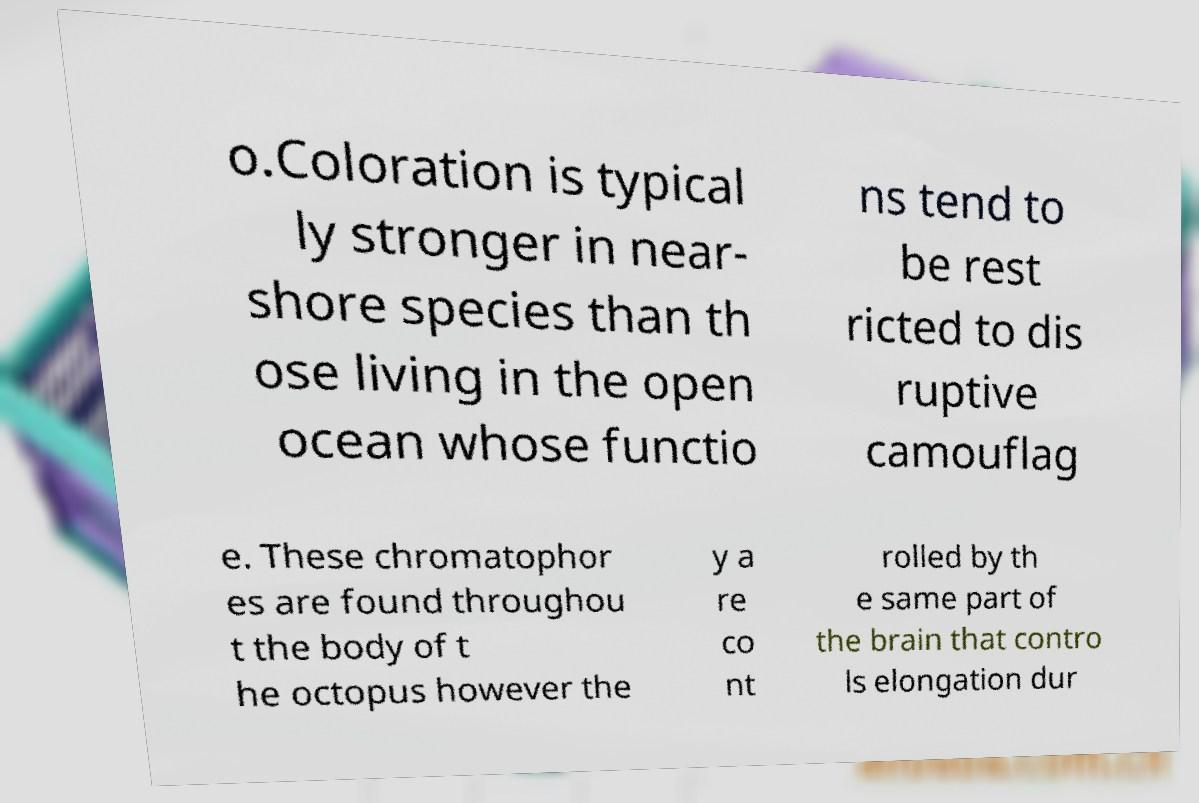I need the written content from this picture converted into text. Can you do that? o.Coloration is typical ly stronger in near- shore species than th ose living in the open ocean whose functio ns tend to be rest ricted to dis ruptive camouflag e. These chromatophor es are found throughou t the body of t he octopus however the y a re co nt rolled by th e same part of the brain that contro ls elongation dur 